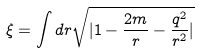Convert formula to latex. <formula><loc_0><loc_0><loc_500><loc_500>\xi = \int d r \sqrt { | 1 - \frac { 2 m } { r } - \frac { q ^ { 2 } } { r ^ { 2 } } | }</formula> 